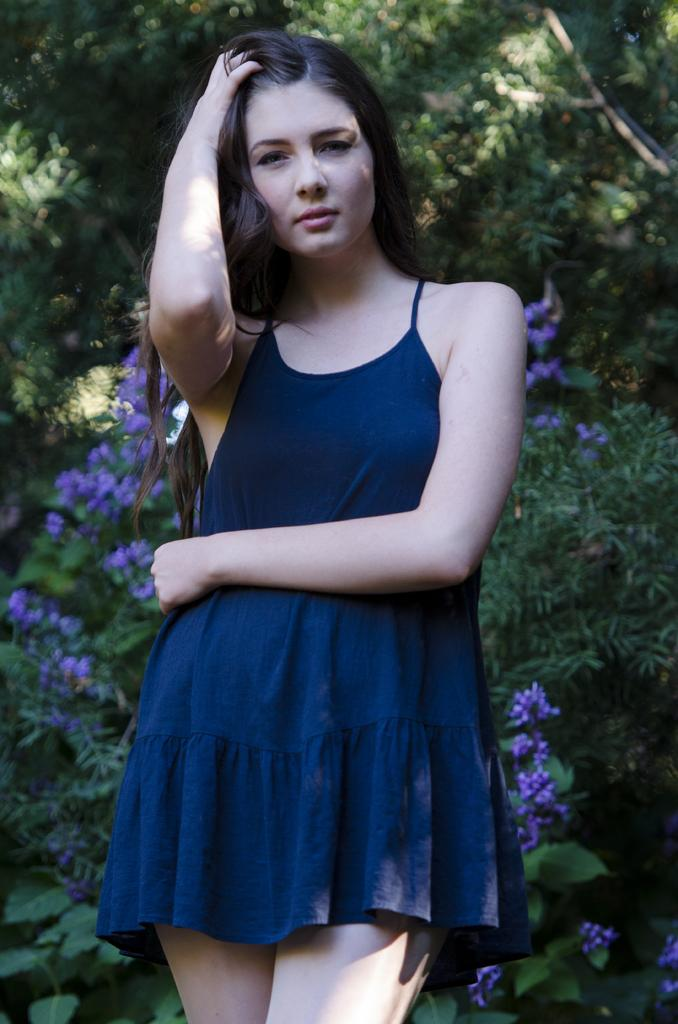Who is the main subject in the image? There is a woman standing in the center of the image. What is the woman wearing? The woman is wearing a blue dress. What can be seen in the background of the image? There are trees and flowers in the background of the image. What color are the flowers? The flowers are in violet color. What type of canvas is the woman painting in the image? There is no canvas or painting activity present in the image. What is the purpose of the protest in the image? There is no protest or any indication of a protest in the image. 